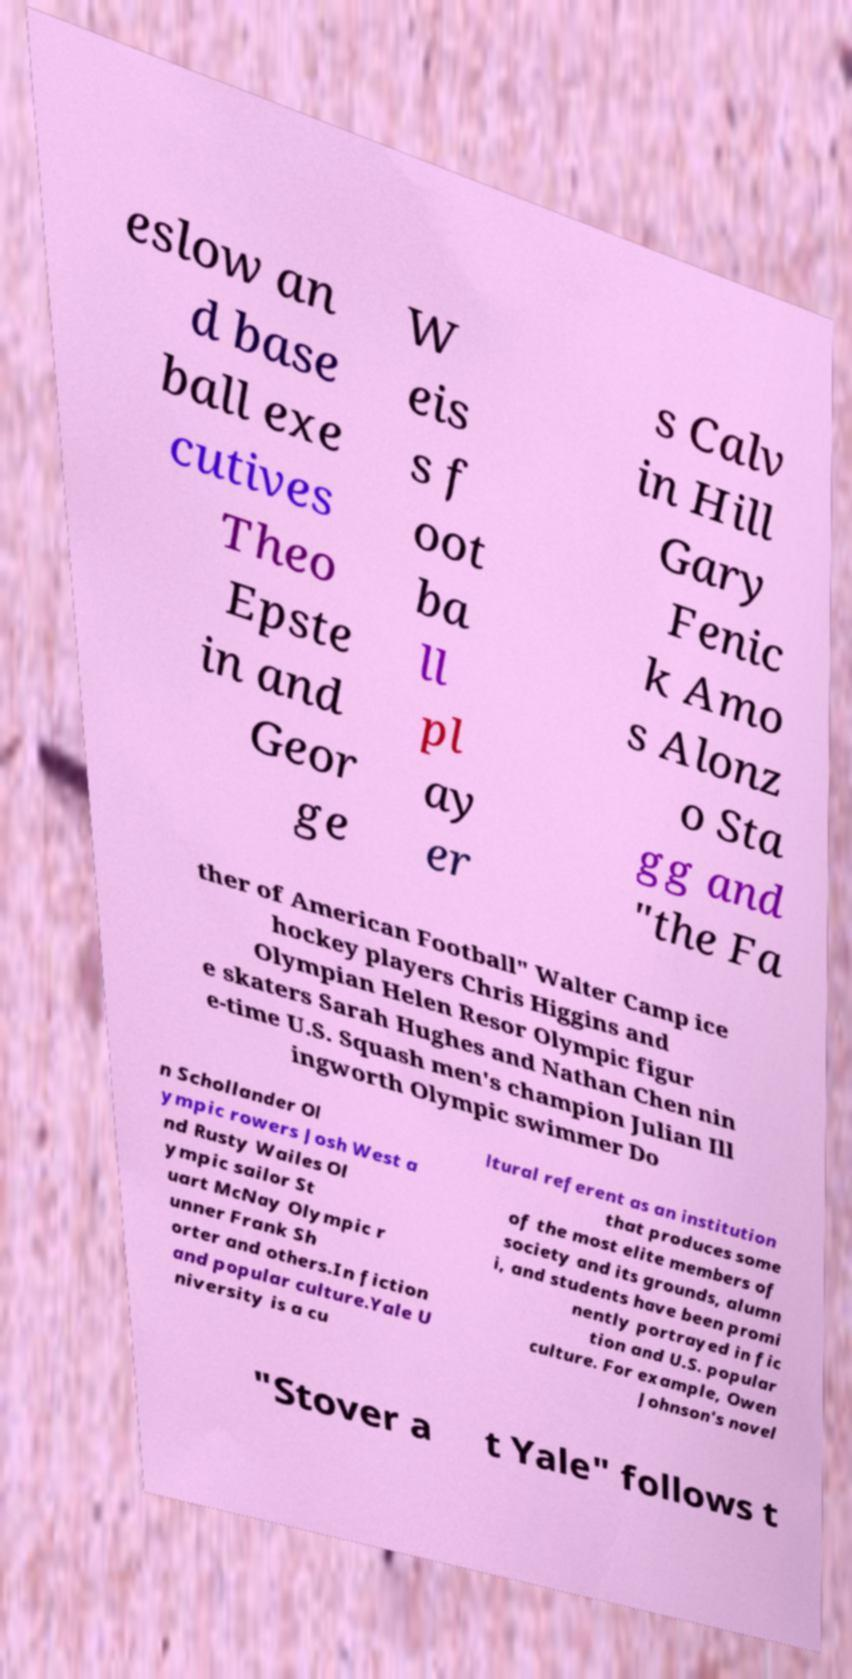For documentation purposes, I need the text within this image transcribed. Could you provide that? eslow an d base ball exe cutives Theo Epste in and Geor ge W eis s f oot ba ll pl ay er s Calv in Hill Gary Fenic k Amo s Alonz o Sta gg and "the Fa ther of American Football" Walter Camp ice hockey players Chris Higgins and Olympian Helen Resor Olympic figur e skaters Sarah Hughes and Nathan Chen nin e-time U.S. Squash men's champion Julian Ill ingworth Olympic swimmer Do n Schollander Ol ympic rowers Josh West a nd Rusty Wailes Ol ympic sailor St uart McNay Olympic r unner Frank Sh orter and others.In fiction and popular culture.Yale U niversity is a cu ltural referent as an institution that produces some of the most elite members of society and its grounds, alumn i, and students have been promi nently portrayed in fic tion and U.S. popular culture. For example, Owen Johnson's novel "Stover a t Yale" follows t 